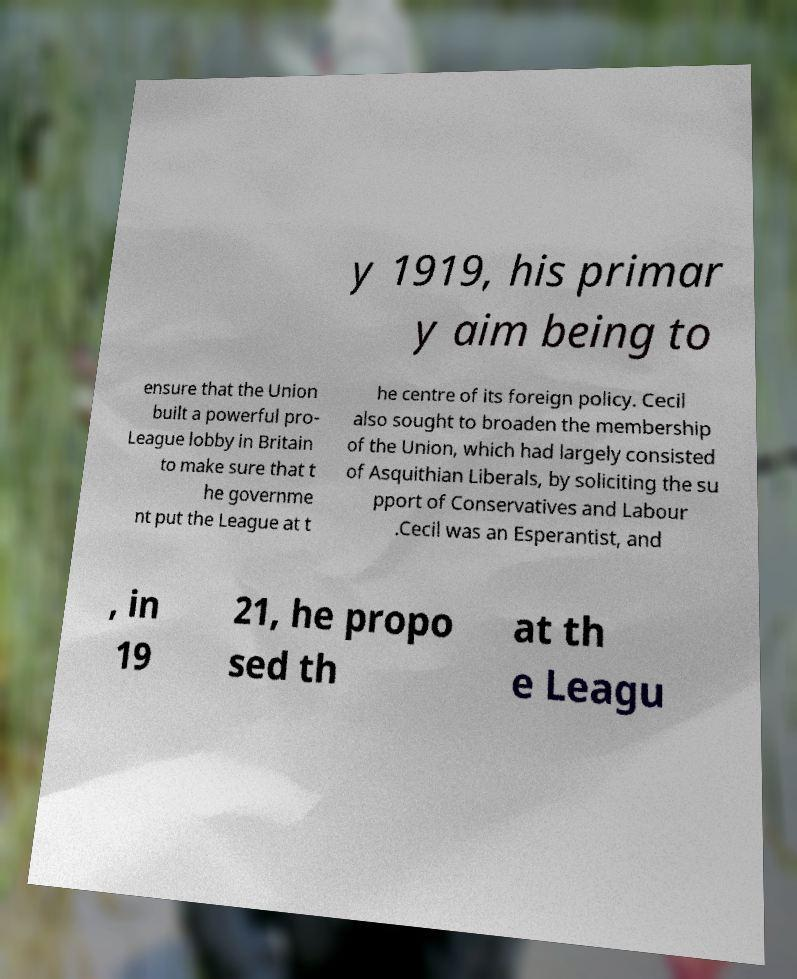Can you accurately transcribe the text from the provided image for me? y 1919, his primar y aim being to ensure that the Union built a powerful pro- League lobby in Britain to make sure that t he governme nt put the League at t he centre of its foreign policy. Cecil also sought to broaden the membership of the Union, which had largely consisted of Asquithian Liberals, by soliciting the su pport of Conservatives and Labour .Cecil was an Esperantist, and , in 19 21, he propo sed th at th e Leagu 